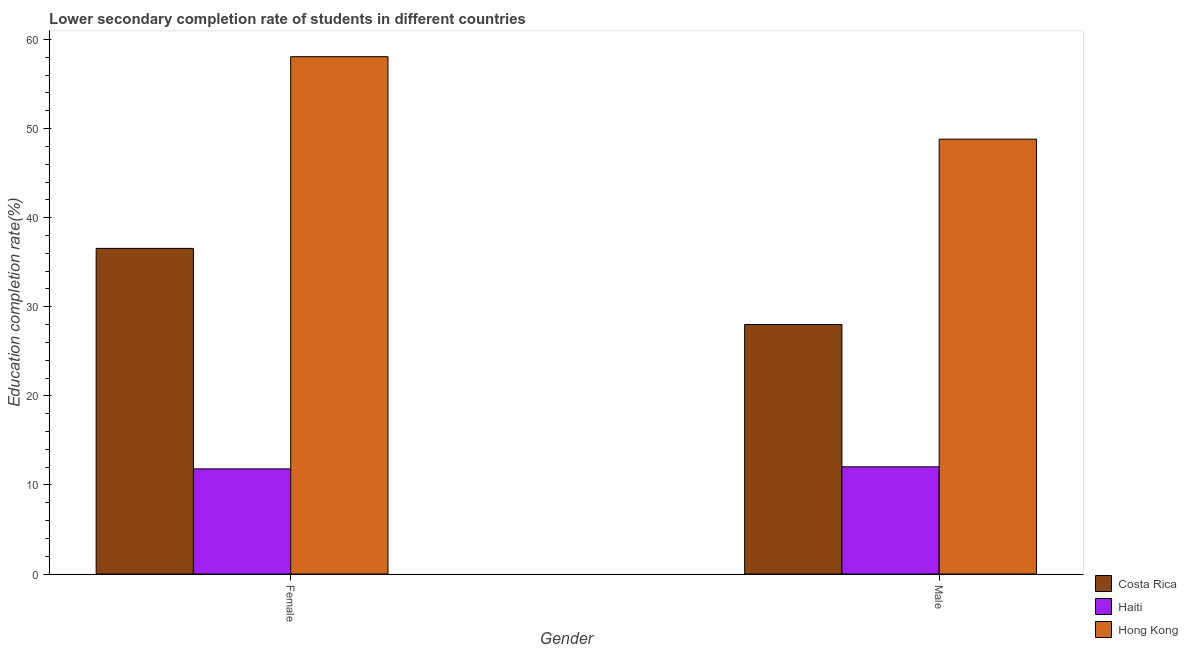How many different coloured bars are there?
Give a very brief answer. 3. How many bars are there on the 2nd tick from the left?
Ensure brevity in your answer.  3. What is the label of the 2nd group of bars from the left?
Make the answer very short. Male. What is the education completion rate of female students in Costa Rica?
Offer a very short reply. 36.55. Across all countries, what is the maximum education completion rate of female students?
Your answer should be compact. 58.07. Across all countries, what is the minimum education completion rate of male students?
Your response must be concise. 12.03. In which country was the education completion rate of male students maximum?
Your answer should be very brief. Hong Kong. In which country was the education completion rate of female students minimum?
Your response must be concise. Haiti. What is the total education completion rate of male students in the graph?
Give a very brief answer. 88.85. What is the difference between the education completion rate of female students in Costa Rica and that in Haiti?
Ensure brevity in your answer.  24.75. What is the difference between the education completion rate of female students in Costa Rica and the education completion rate of male students in Hong Kong?
Ensure brevity in your answer.  -12.26. What is the average education completion rate of male students per country?
Provide a short and direct response. 29.62. What is the difference between the education completion rate of male students and education completion rate of female students in Haiti?
Make the answer very short. 0.23. What is the ratio of the education completion rate of female students in Haiti to that in Costa Rica?
Your answer should be compact. 0.32. Is the education completion rate of female students in Costa Rica less than that in Hong Kong?
Offer a terse response. Yes. What does the 1st bar from the right in Male represents?
Your response must be concise. Hong Kong. Are all the bars in the graph horizontal?
Give a very brief answer. No. How many countries are there in the graph?
Your answer should be compact. 3. What is the difference between two consecutive major ticks on the Y-axis?
Keep it short and to the point. 10. Does the graph contain any zero values?
Ensure brevity in your answer.  No. Where does the legend appear in the graph?
Your answer should be compact. Bottom right. How many legend labels are there?
Keep it short and to the point. 3. What is the title of the graph?
Offer a terse response. Lower secondary completion rate of students in different countries. Does "United Kingdom" appear as one of the legend labels in the graph?
Provide a succinct answer. No. What is the label or title of the X-axis?
Give a very brief answer. Gender. What is the label or title of the Y-axis?
Ensure brevity in your answer.  Education completion rate(%). What is the Education completion rate(%) of Costa Rica in Female?
Offer a terse response. 36.55. What is the Education completion rate(%) of Haiti in Female?
Keep it short and to the point. 11.8. What is the Education completion rate(%) of Hong Kong in Female?
Provide a short and direct response. 58.07. What is the Education completion rate(%) of Costa Rica in Male?
Ensure brevity in your answer.  28. What is the Education completion rate(%) of Haiti in Male?
Your answer should be compact. 12.03. What is the Education completion rate(%) in Hong Kong in Male?
Offer a terse response. 48.81. Across all Gender, what is the maximum Education completion rate(%) of Costa Rica?
Give a very brief answer. 36.55. Across all Gender, what is the maximum Education completion rate(%) of Haiti?
Ensure brevity in your answer.  12.03. Across all Gender, what is the maximum Education completion rate(%) in Hong Kong?
Your answer should be compact. 58.07. Across all Gender, what is the minimum Education completion rate(%) in Costa Rica?
Provide a short and direct response. 28. Across all Gender, what is the minimum Education completion rate(%) in Haiti?
Make the answer very short. 11.8. Across all Gender, what is the minimum Education completion rate(%) of Hong Kong?
Your response must be concise. 48.81. What is the total Education completion rate(%) in Costa Rica in the graph?
Provide a short and direct response. 64.56. What is the total Education completion rate(%) of Haiti in the graph?
Offer a very short reply. 23.83. What is the total Education completion rate(%) in Hong Kong in the graph?
Offer a terse response. 106.89. What is the difference between the Education completion rate(%) in Costa Rica in Female and that in Male?
Make the answer very short. 8.55. What is the difference between the Education completion rate(%) of Haiti in Female and that in Male?
Your response must be concise. -0.23. What is the difference between the Education completion rate(%) of Hong Kong in Female and that in Male?
Your response must be concise. 9.26. What is the difference between the Education completion rate(%) of Costa Rica in Female and the Education completion rate(%) of Haiti in Male?
Keep it short and to the point. 24.52. What is the difference between the Education completion rate(%) of Costa Rica in Female and the Education completion rate(%) of Hong Kong in Male?
Provide a succinct answer. -12.26. What is the difference between the Education completion rate(%) in Haiti in Female and the Education completion rate(%) in Hong Kong in Male?
Offer a terse response. -37.02. What is the average Education completion rate(%) in Costa Rica per Gender?
Ensure brevity in your answer.  32.28. What is the average Education completion rate(%) in Haiti per Gender?
Keep it short and to the point. 11.92. What is the average Education completion rate(%) of Hong Kong per Gender?
Give a very brief answer. 53.44. What is the difference between the Education completion rate(%) in Costa Rica and Education completion rate(%) in Haiti in Female?
Make the answer very short. 24.75. What is the difference between the Education completion rate(%) of Costa Rica and Education completion rate(%) of Hong Kong in Female?
Provide a short and direct response. -21.52. What is the difference between the Education completion rate(%) in Haiti and Education completion rate(%) in Hong Kong in Female?
Provide a succinct answer. -46.27. What is the difference between the Education completion rate(%) of Costa Rica and Education completion rate(%) of Haiti in Male?
Make the answer very short. 15.97. What is the difference between the Education completion rate(%) in Costa Rica and Education completion rate(%) in Hong Kong in Male?
Your answer should be very brief. -20.81. What is the difference between the Education completion rate(%) in Haiti and Education completion rate(%) in Hong Kong in Male?
Provide a short and direct response. -36.78. What is the ratio of the Education completion rate(%) of Costa Rica in Female to that in Male?
Provide a succinct answer. 1.31. What is the ratio of the Education completion rate(%) of Haiti in Female to that in Male?
Provide a succinct answer. 0.98. What is the ratio of the Education completion rate(%) in Hong Kong in Female to that in Male?
Your response must be concise. 1.19. What is the difference between the highest and the second highest Education completion rate(%) of Costa Rica?
Provide a short and direct response. 8.55. What is the difference between the highest and the second highest Education completion rate(%) in Haiti?
Your answer should be compact. 0.23. What is the difference between the highest and the second highest Education completion rate(%) of Hong Kong?
Ensure brevity in your answer.  9.26. What is the difference between the highest and the lowest Education completion rate(%) in Costa Rica?
Your answer should be compact. 8.55. What is the difference between the highest and the lowest Education completion rate(%) in Haiti?
Give a very brief answer. 0.23. What is the difference between the highest and the lowest Education completion rate(%) in Hong Kong?
Keep it short and to the point. 9.26. 